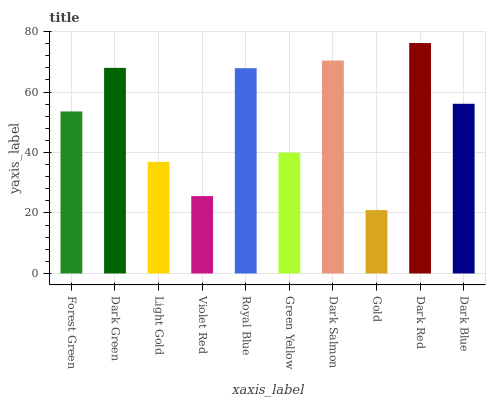Is Gold the minimum?
Answer yes or no. Yes. Is Dark Red the maximum?
Answer yes or no. Yes. Is Dark Green the minimum?
Answer yes or no. No. Is Dark Green the maximum?
Answer yes or no. No. Is Dark Green greater than Forest Green?
Answer yes or no. Yes. Is Forest Green less than Dark Green?
Answer yes or no. Yes. Is Forest Green greater than Dark Green?
Answer yes or no. No. Is Dark Green less than Forest Green?
Answer yes or no. No. Is Dark Blue the high median?
Answer yes or no. Yes. Is Forest Green the low median?
Answer yes or no. Yes. Is Violet Red the high median?
Answer yes or no. No. Is Light Gold the low median?
Answer yes or no. No. 